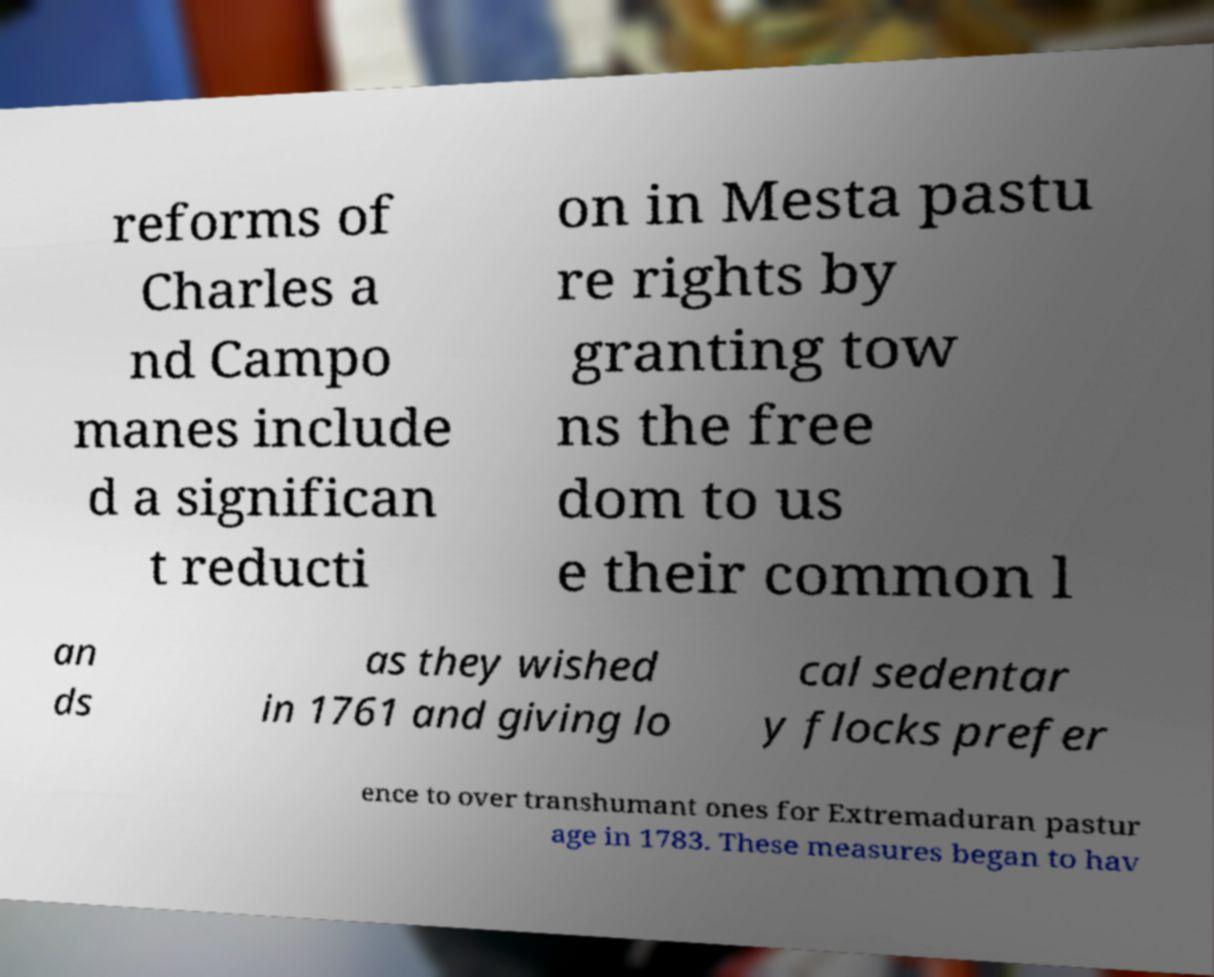Can you read and provide the text displayed in the image?This photo seems to have some interesting text. Can you extract and type it out for me? reforms of Charles a nd Campo manes include d a significan t reducti on in Mesta pastu re rights by granting tow ns the free dom to us e their common l an ds as they wished in 1761 and giving lo cal sedentar y flocks prefer ence to over transhumant ones for Extremaduran pastur age in 1783. These measures began to hav 